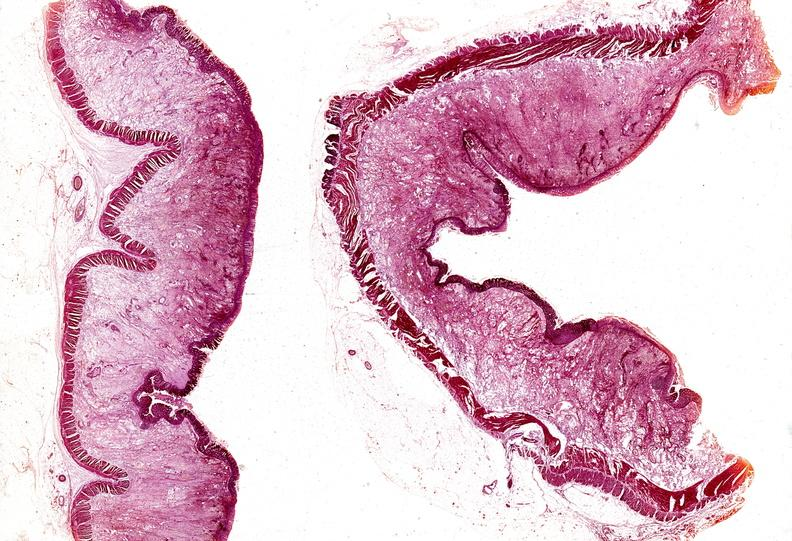does inflamed exocervix show colon, ulcerative colitis?
Answer the question using a single word or phrase. No 